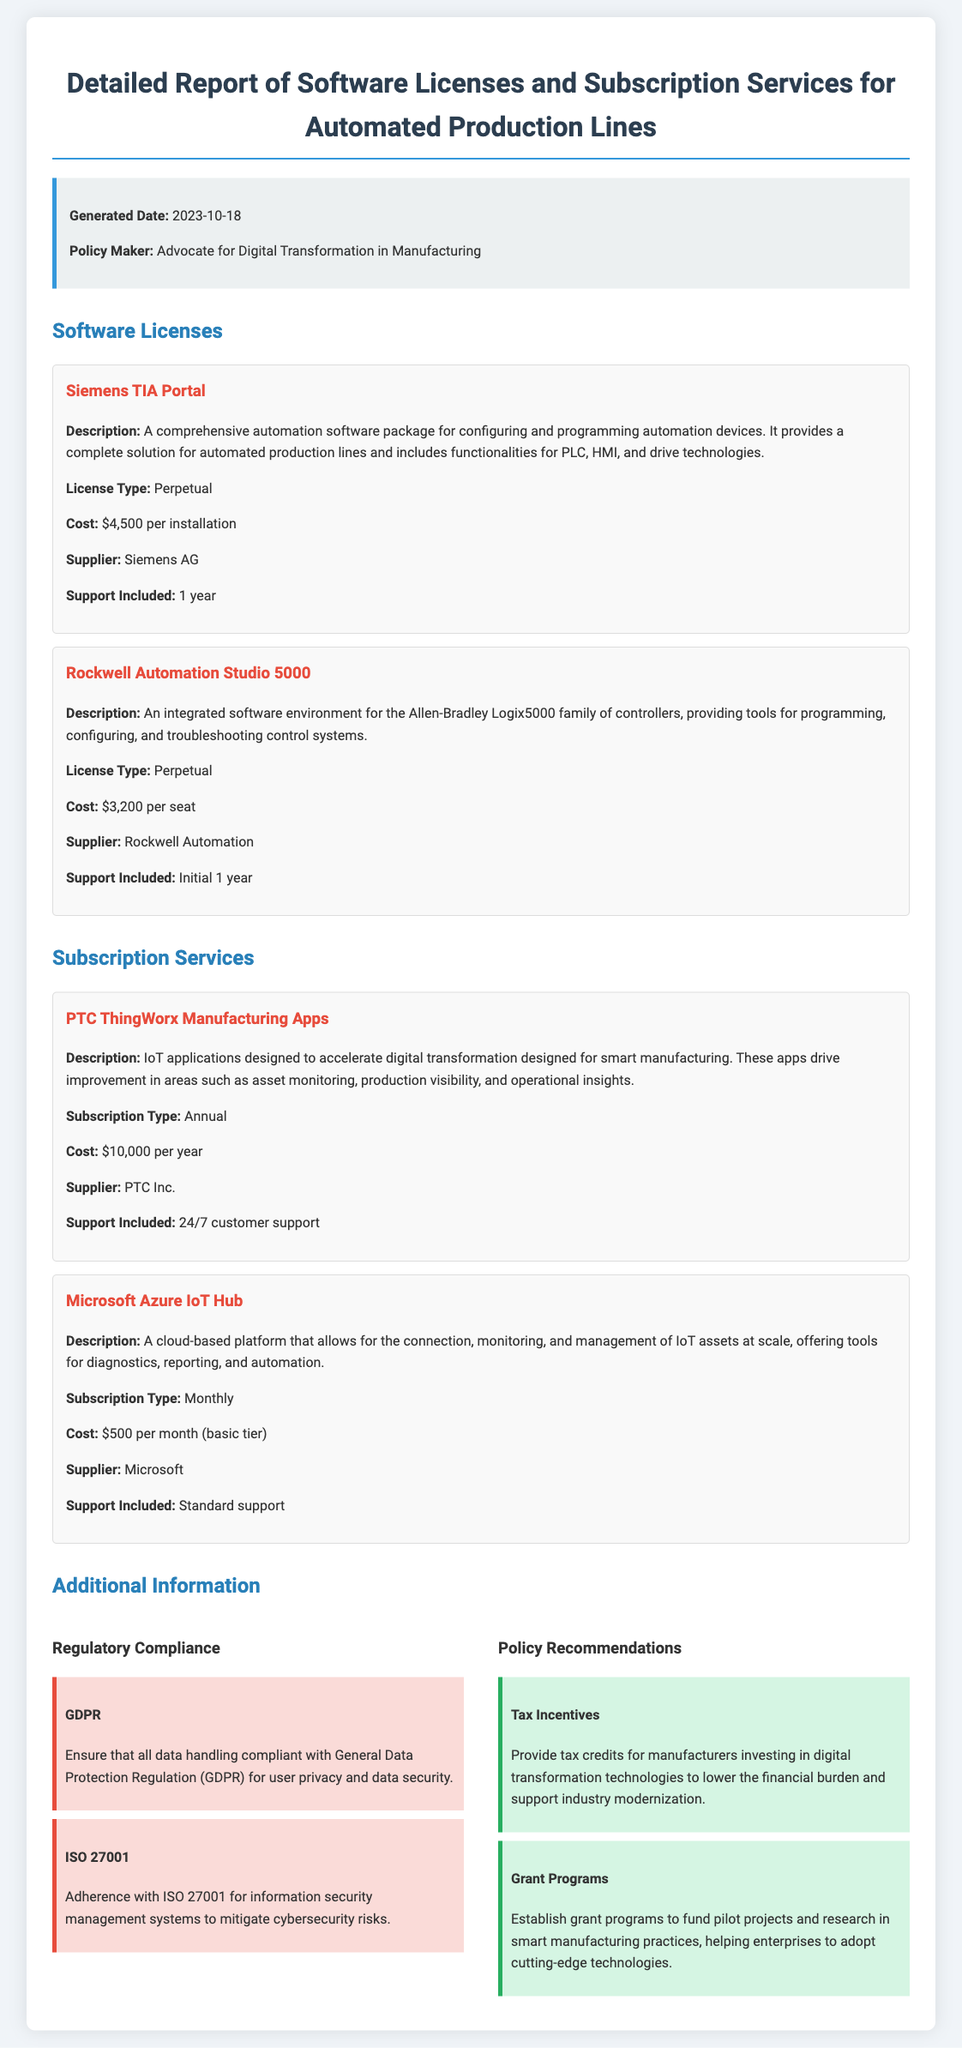what is the generated date of the report? The generated date is mentioned at the beginning of the report.
Answer: 2023-10-18 who is the policy maker advocating for digital transformation? The report specifies the policy maker's role at the top.
Answer: Advocate for Digital Transformation in Manufacturing what is the cost of Siemens TIA Portal? The report clearly indicates the cost associated with this software license.
Answer: $4,500 per installation what type of subscription is PTC ThingWorx Manufacturing Apps? The type of subscription for this service is stated in the report.
Answer: Annual how long is the support included for Rockwell Automation Studio 5000? The report mentions the duration of support specifically included with this software.
Answer: Initial 1 year what regulatory compliance is associated with GDPR? The report discusses compliance requirements related to data handling.
Answer: General Data Protection Regulation which policy recommendation suggests providing tax credits? The report includes specific recommendations for policy incentives.
Answer: Tax Incentives what is the monthly cost of Microsoft Azure IoT Hub? The report provides detailed pricing for subscription services.
Answer: $500 per month (basic tier) 